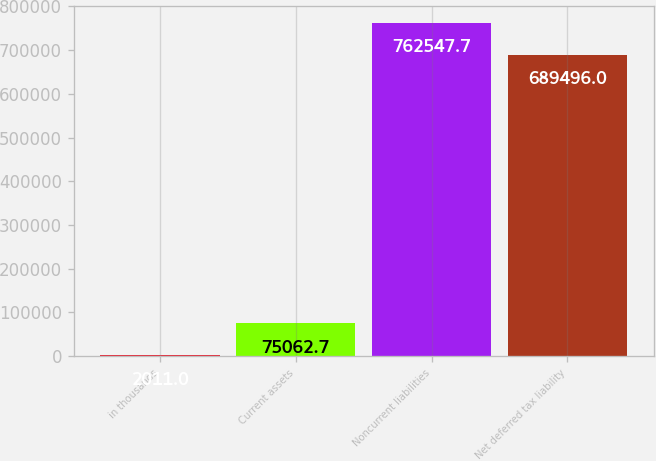Convert chart to OTSL. <chart><loc_0><loc_0><loc_500><loc_500><bar_chart><fcel>in thousands<fcel>Current assets<fcel>Noncurrent liabilities<fcel>Net deferred tax liability<nl><fcel>2011<fcel>75062.7<fcel>762548<fcel>689496<nl></chart> 